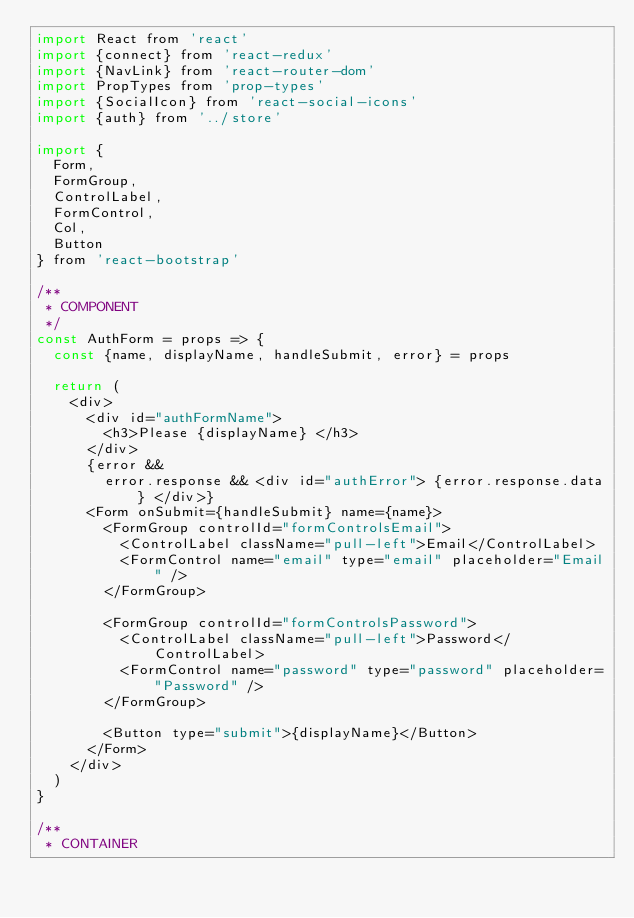Convert code to text. <code><loc_0><loc_0><loc_500><loc_500><_JavaScript_>import React from 'react'
import {connect} from 'react-redux'
import {NavLink} from 'react-router-dom'
import PropTypes from 'prop-types'
import {SocialIcon} from 'react-social-icons'
import {auth} from '../store'

import {
  Form,
  FormGroup,
  ControlLabel,
  FormControl,
  Col,
  Button
} from 'react-bootstrap'

/**
 * COMPONENT
 */
const AuthForm = props => {
  const {name, displayName, handleSubmit, error} = props

  return (
    <div>
      <div id="authFormName">
        <h3>Please {displayName} </h3>
      </div>
      {error &&
        error.response && <div id="authError"> {error.response.data} </div>}
      <Form onSubmit={handleSubmit} name={name}>
        <FormGroup controlId="formControlsEmail">
          <ControlLabel className="pull-left">Email</ControlLabel>
          <FormControl name="email" type="email" placeholder="Email" />
        </FormGroup>

        <FormGroup controlId="formControlsPassword">
          <ControlLabel className="pull-left">Password</ControlLabel>
          <FormControl name="password" type="password" placeholder="Password" />
        </FormGroup>

        <Button type="submit">{displayName}</Button>
      </Form>
    </div>
  )
}

/**
 * CONTAINER</code> 